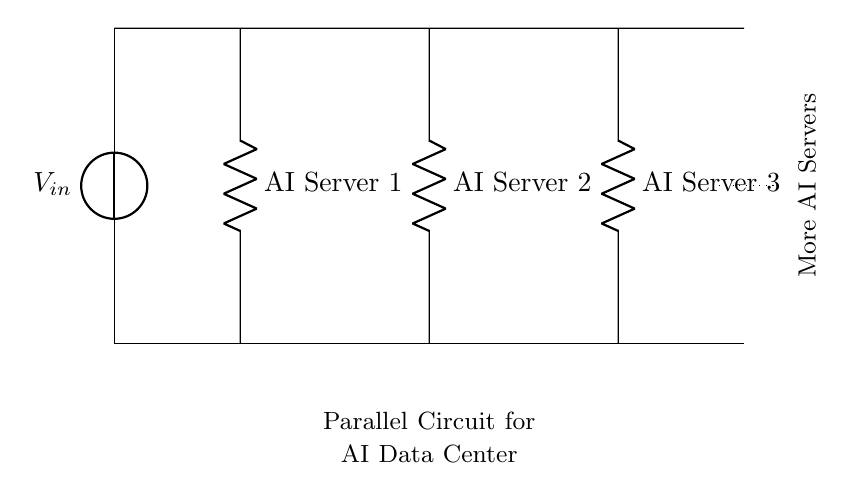What is the input voltage of the circuit? The diagram indicates the input voltage as labeled with \( V_{in} \), which signifies the voltage supplied to the circuit. Since the exact value isn't provided in this context, we take it as the standard \( V_{in} \).
Answer: \( V_{in} \) How many AI servers are shown in the circuit? The circuit clearly depicts three AI servers labeled as 'AI Server 1', 'AI Server 2', and 'AI Server 3'. Each unit is connected to the main bus in a parallel configuration.
Answer: 3 Which type of circuit is represented? The arrangement of the components shows multiple connections branching off from a single source, a characteristic of parallel circuits designed to supply equal voltage across each component.
Answer: Parallel What happens to the total current in the circuit? In a parallel circuit, the total current supplied by the source is the sum of the currents through each branch. Each server draws its current based on its resistance, adding up to a larger total current drawn from the source as compared to a single path.
Answer: Increases What is indicated by the dotted line in the circuit? The dotted line signifies that there is the potential for additional connections or servers beyond the three explicitly shown, implying scalability and expansion options in the data center's power setup.
Answer: More servers Which component represents an AI server in this circuit? The resistors labeled as 'AI Server 1', 'AI Server 2', and 'AI Server 3' represent the AI servers in the circuit, thereby showcasing each server's resistance in the overall configuration.
Answer: Resistor 